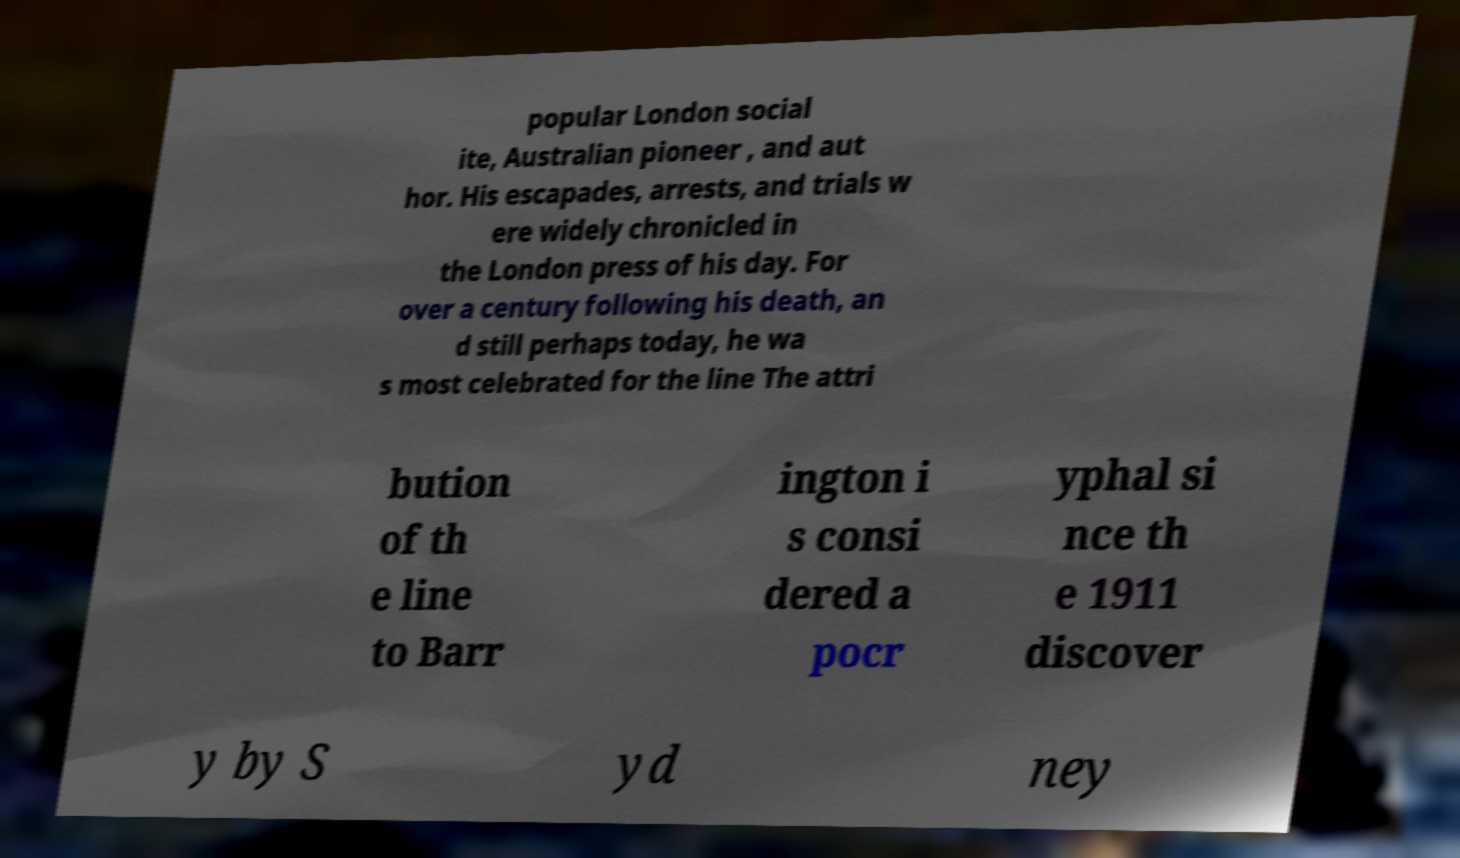Can you read and provide the text displayed in the image?This photo seems to have some interesting text. Can you extract and type it out for me? popular London social ite, Australian pioneer , and aut hor. His escapades, arrests, and trials w ere widely chronicled in the London press of his day. For over a century following his death, an d still perhaps today, he wa s most celebrated for the line The attri bution of th e line to Barr ington i s consi dered a pocr yphal si nce th e 1911 discover y by S yd ney 